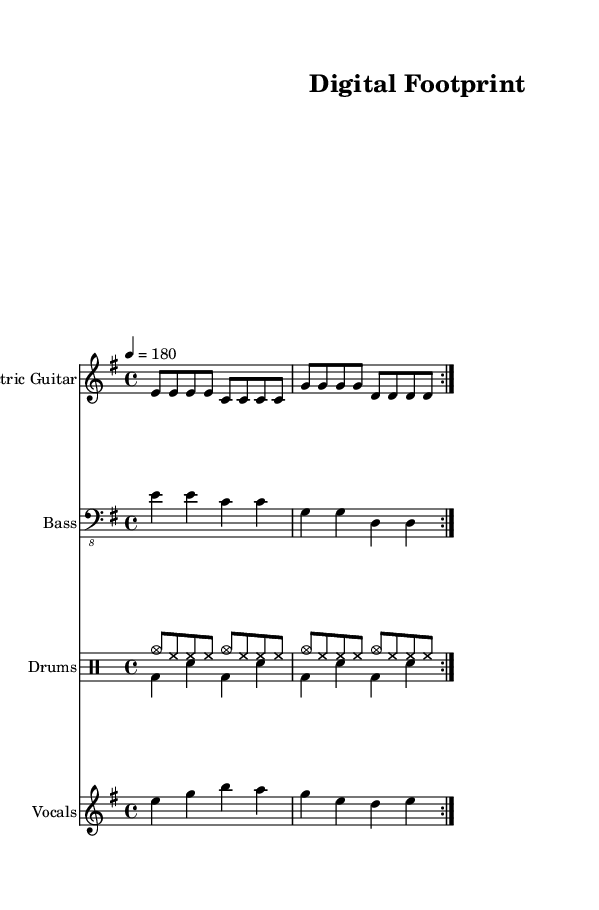What is the key signature of this music? The key signature is E minor, which has one sharp (F#). This can be identified by looking at the key signature indicated at the beginning of the sheet music.
Answer: E minor What is the time signature of this music? The time signature is 4/4, which means there are four beats in each measure, and the quarter note gets one beat. This is indicated at the start of the score.
Answer: 4/4 What is the tempo marking of this music? The tempo marking is 180 BPM (beats per minute), indicated by the tempo notation "4 = 180" at the beginning of the score. This informs performers to play at a fast pace.
Answer: 180 How many measures are repeated in the electric guitar part? The electric guitar part includes a repeated section that is marked with "volta 2," indicating that the section is played twice. Each repeat consists of four measures.
Answer: 2 What is the primary theme of the lyrics? The lyrics focus on data privacy and online surveillance, as indicated by the lines discussing cookies and big data knowing users' actions. This theme relates closely to the contemporary concerns surrounding digital privacy.
Answer: Data privacy What role does the bass guitar play in relation to the electric guitar? The bass guitar complements the electric guitar by providing the foundation and rhythmic support, playing deeper notes that harmonize with the guitar part. This is typical in punk music, helping to drive the overall sound.
Answer: Foundation What style of vocals is used in this track? The style of vocals is straightforward and aggressive, characteristic of punk music, which often features direct and impactful lyrical delivery to match the fast-paced instrumentals. This can be inferred from the vocal melody and the way the lyrics are presented.
Answer: Aggressive 